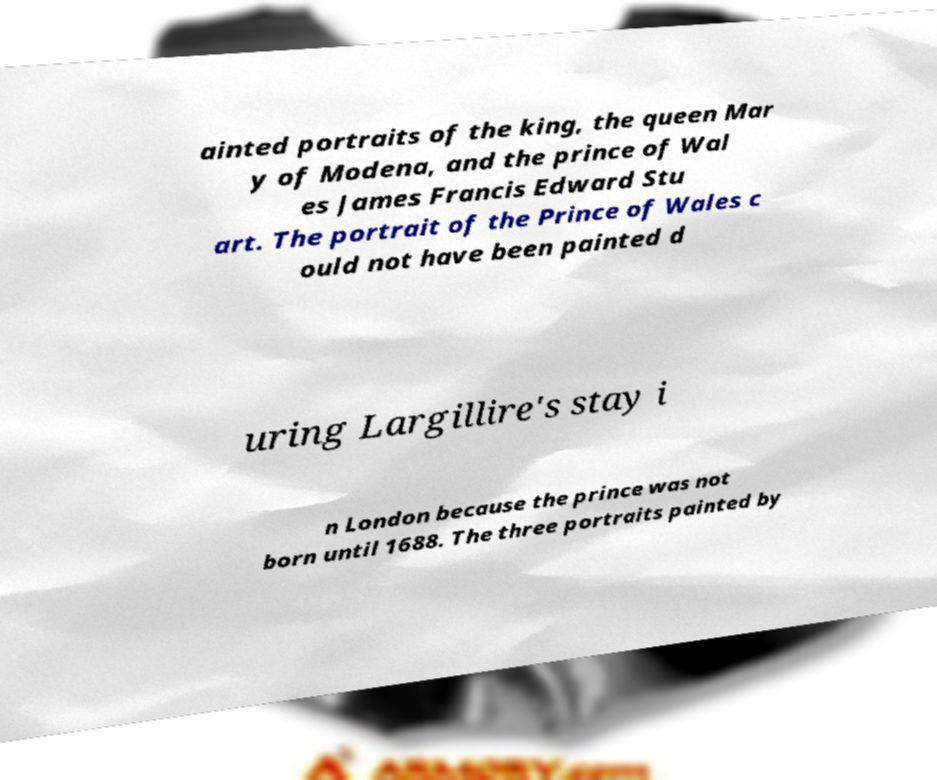Can you read and provide the text displayed in the image?This photo seems to have some interesting text. Can you extract and type it out for me? ainted portraits of the king, the queen Mar y of Modena, and the prince of Wal es James Francis Edward Stu art. The portrait of the Prince of Wales c ould not have been painted d uring Largillire's stay i n London because the prince was not born until 1688. The three portraits painted by 